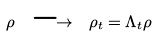Convert formula to latex. <formula><loc_0><loc_0><loc_500><loc_500>\rho \ \longrightarrow \ \rho _ { t } = \Lambda _ { t } \rho</formula> 